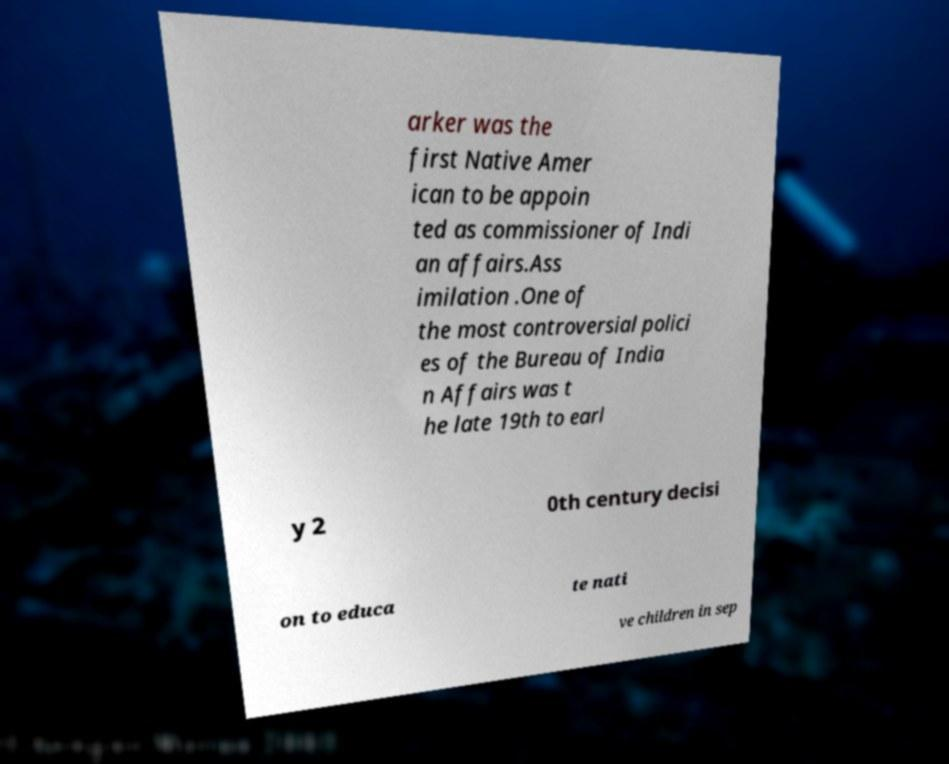Can you read and provide the text displayed in the image?This photo seems to have some interesting text. Can you extract and type it out for me? arker was the first Native Amer ican to be appoin ted as commissioner of Indi an affairs.Ass imilation .One of the most controversial polici es of the Bureau of India n Affairs was t he late 19th to earl y 2 0th century decisi on to educa te nati ve children in sep 